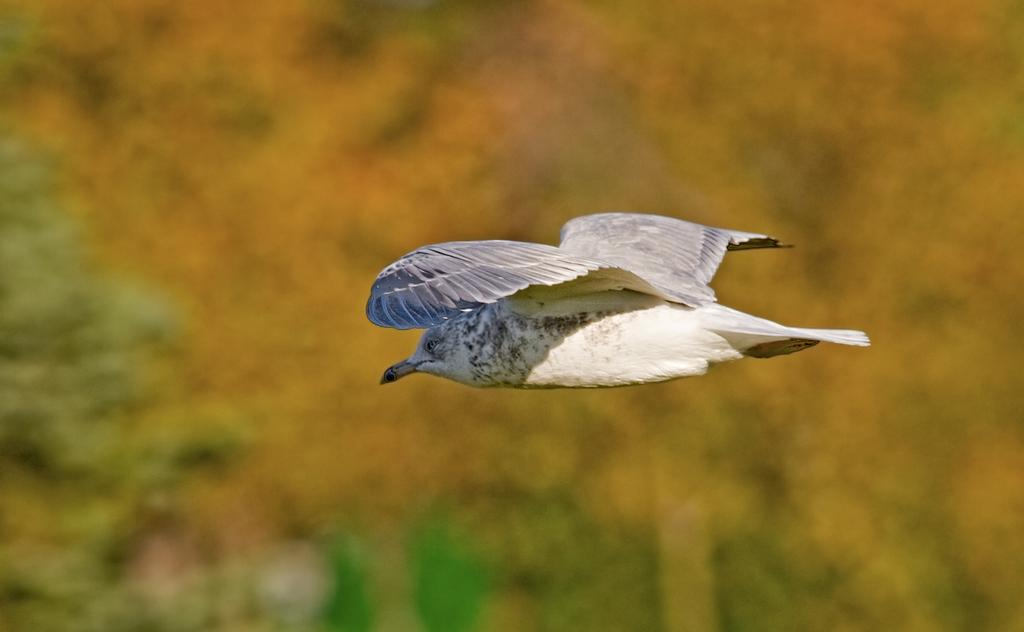What is the main subject of the image? There is a bird flying in the image. Can you describe the background of the image? The background of the image is blurry. Where is the crown placed on the bird in the image? There is no crown present on the bird in the image. What type of treatment is the bird receiving in the image? There is no indication in the image that the bird is receiving any treatment. 